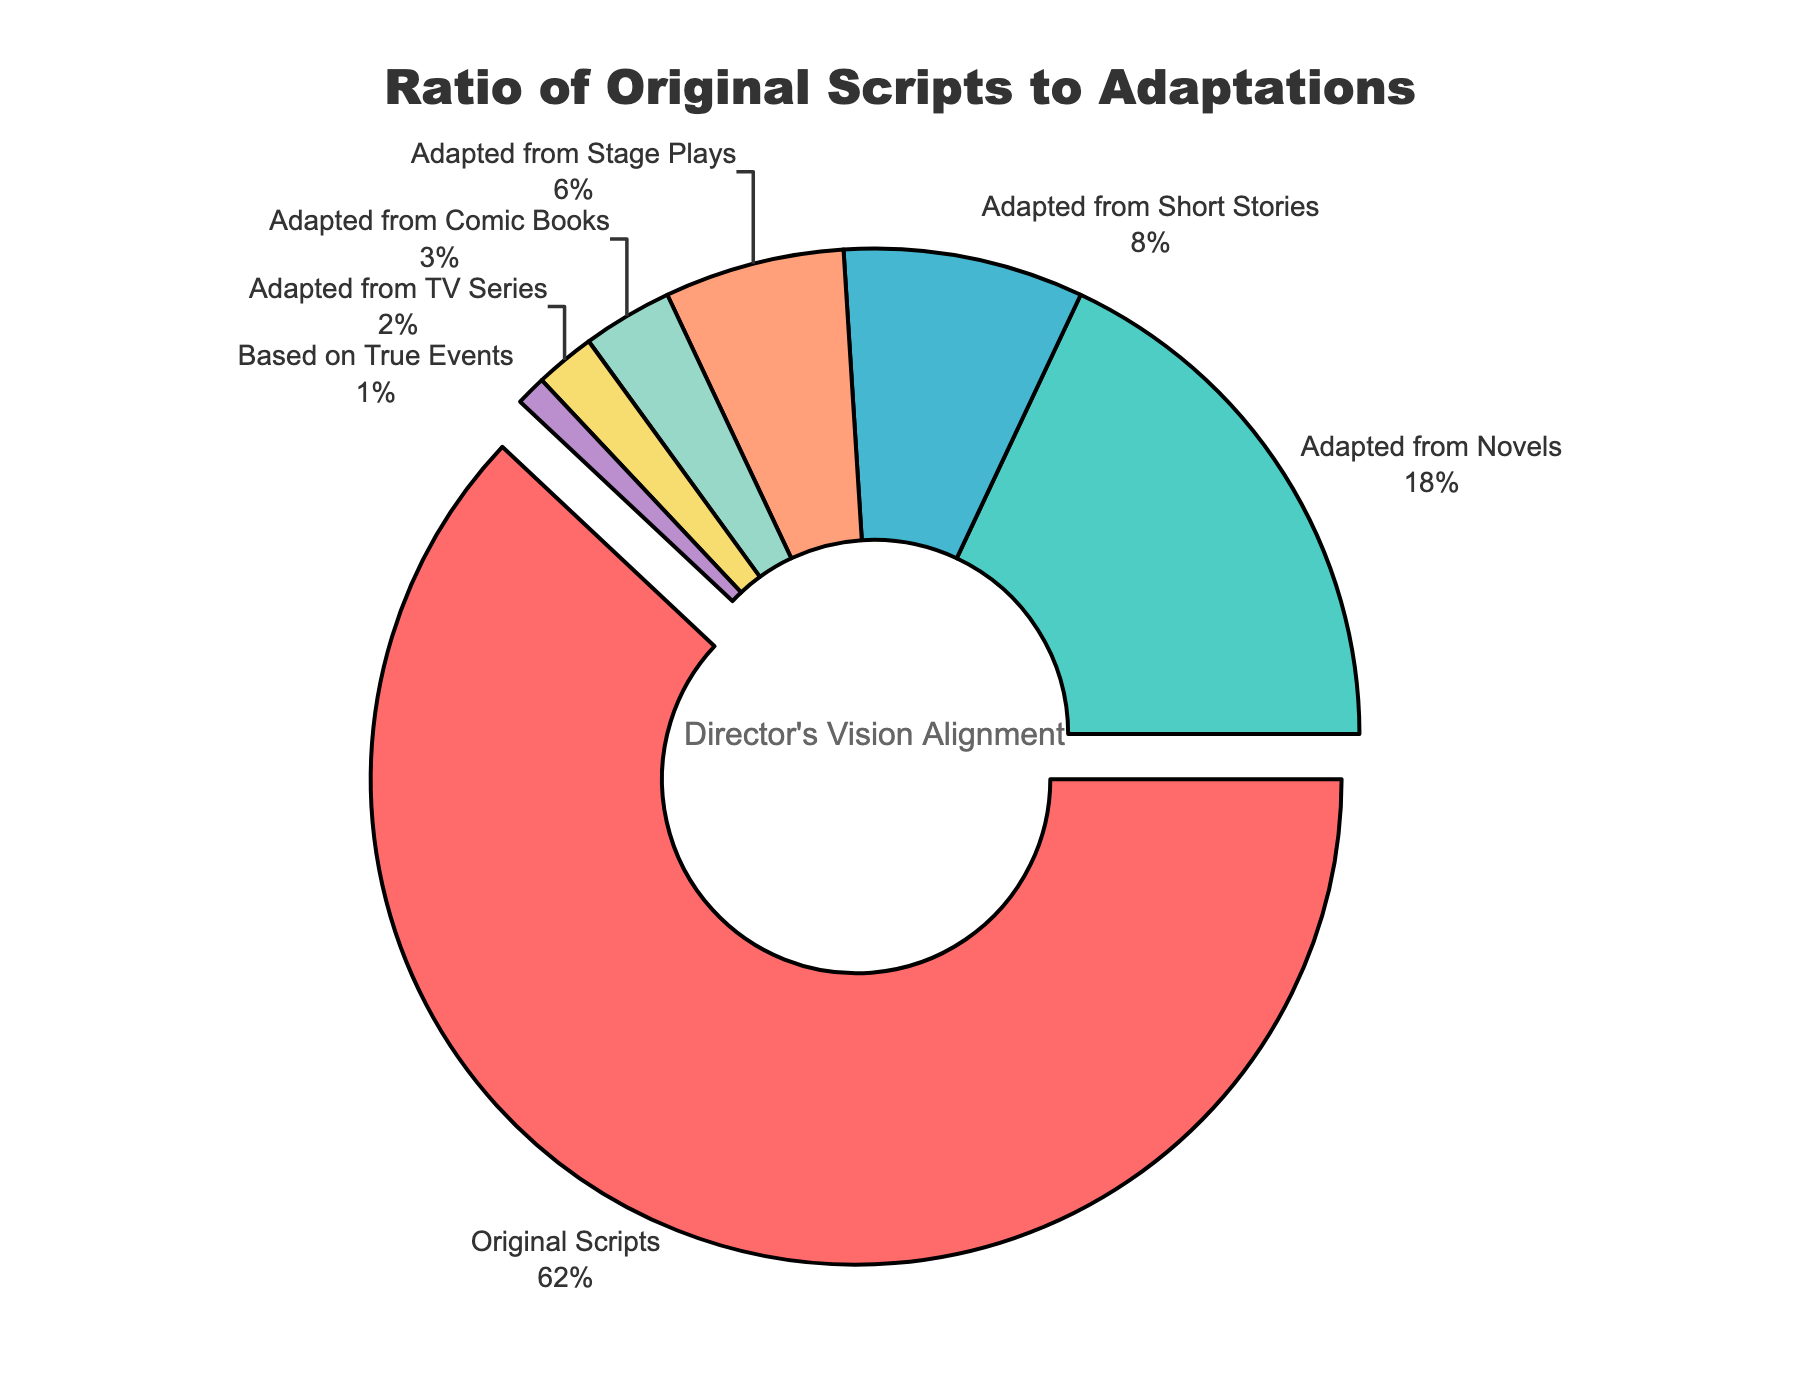What percentage of the curated selection is made up of original scripts? The section labeled "Original Scripts" in the pie chart occupies 62% of the total area.
Answer: 62% What are the top two categories by percentage in the curated selection? The two largest sections of the pie chart are "Original Scripts" (62%) and "Adapted from Novels" (18%).
Answer: Original Scripts and Adapted from Novels Which category occupies the smallest percentage in the pie chart? The section labeled "Based on True Events" in the pie chart occupies the smallest percentage, at 1%.
Answer: Based on True Events What is the combined percentage of adaptations from novels and comic books? The sections labeled "Adapted from Novels" (18%) and "Adapted from Comic Books" (3%) in the pie chart together sum up to 18% + 3% = 21%.
Answer: 21% How much larger is the percentage of original scripts compared to adaptations from TV series? The section for "Original Scripts" is 62%, and the section for "Adapted from TV Series" is 2%. The difference is 62% - 2% = 60%.
Answer: 60% Which categories are visually depicted in shades of green or teal? By observing the colors used in the pie chart, the categories "Adapted from Novels" (green) and "Adapted from Stage Plays" (teal) can be identified.
Answer: Adapted from Novels and Adapted from Stage Plays What is the total percentage of all adaptation categories excluding original scripts? The adaptation categories include Adapted from Novels (18%), Adapted from Short Stories (8%), Adapted from Stage Plays (6%), Adapted from Comic Books (3%), Adapted from TV Series (2%), and Based on True Events (1%). Summing these gives 18% + 8% + 6% + 3% + 2% + 1% = 38%.
Answer: 38% Is the percentage of adaptations from stage plays greater or less than adaptations from short stories? The percentage for "Adapted from Stage Plays" is 6%, and for "Adapted from Short Stories" is 8%. Comparing these gives 6% < 8%.
Answer: Less What visual feature highlights the category "Original Scripts" in the pie chart? The "Original Scripts" section is pulled out slightly from the pie chart to emphasize its importance.
Answer: Pulled out 